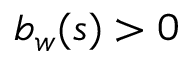Convert formula to latex. <formula><loc_0><loc_0><loc_500><loc_500>b _ { w } ( s ) > 0</formula> 